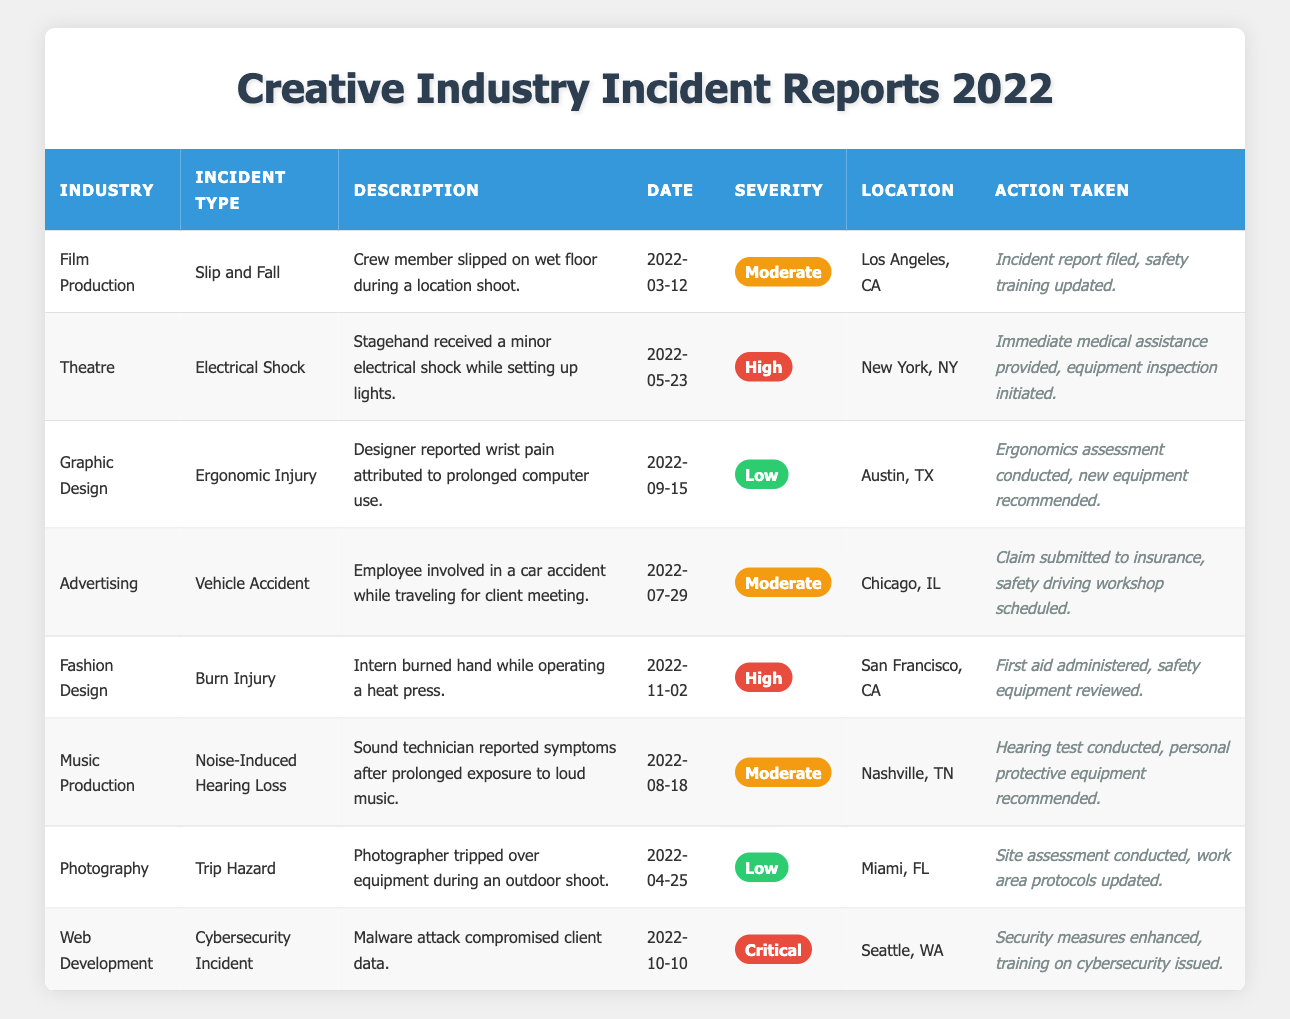What type of incident occurred in the Film Production industry? The table lists "Slip and Fall" as the incident type under the "Film Production" industry.
Answer: Slip and Fall What was the severity of the incident that involved electrical shock? The table indicates that the incident involving electrical shock in the Theatre industry had a severity rating of "High".
Answer: High How many incidents with a severity of Low are recorded in the table? The table shows two incidents with a severity of Low, which are the "Ergonomic Injury" in Graphic Design and "Trip Hazard" in Photography.
Answer: 2 In which city did the vehicle accident take place? According to the table, the vehicle accident occurred in Chicago, IL, as specified in the Advertising industry section.
Answer: Chicago, IL How many incidents were categorized as Moderate? Checking the table, there are four incidents categorized as Moderate: Slip and Fall (Film Production), Vehicle Accident (Advertising), Noise-Induced Hearing Loss (Music Production), and one more incident.
Answer: 4 What actions were taken after the burn injury incident? The table states that after the burn injury incident in Fashion Design, first aid was administered and safety equipment was reviewed.
Answer: First aid administered, safety equipment reviewed Which industry had the highest severity incident reported, and what was the type? The highest severity incident reported was in the Web Development industry, categorized as a Cybersecurity Incident with a severity of Critical.
Answer: Web Development, Cybersecurity Incident What is the most common type of incident concerning severe injuries? The table indicates that there are two incidents categorized as High severity: Electrical Shock in Theatre and Burn Injury in Fashion Design. Both are severe but categorized into different types.
Answer: Electrical Shock and Burn Injury What city recorded an incident due to ergonomic injury? The Ergonomic Injury incident in Graphic Design is recorded in Austin, TX according to the table.
Answer: Austin, TX Was any action taken regarding the Cybersecurity Incident? Yes, the table indicates that security measures were enhanced and training on cybersecurity was issued after the incident.
Answer: Yes How does the number of incidents categorized as High severity compare to those categorized as Critical? There are two incidents categorized as High severity (Electrical Shock and Burn Injury) and one incident categorized as Critical (Cybersecurity Incident). Thus, High severity incidents are greater in number.
Answer: Higher What trend can be inferred about the severity of incidents reported in the music production industry? The table shows that there was a Moderate severity incident reported in the Music Production industry, indicating that while it is a concern, it did not reach a High or Critical level.
Answer: Moderate severity was reported 